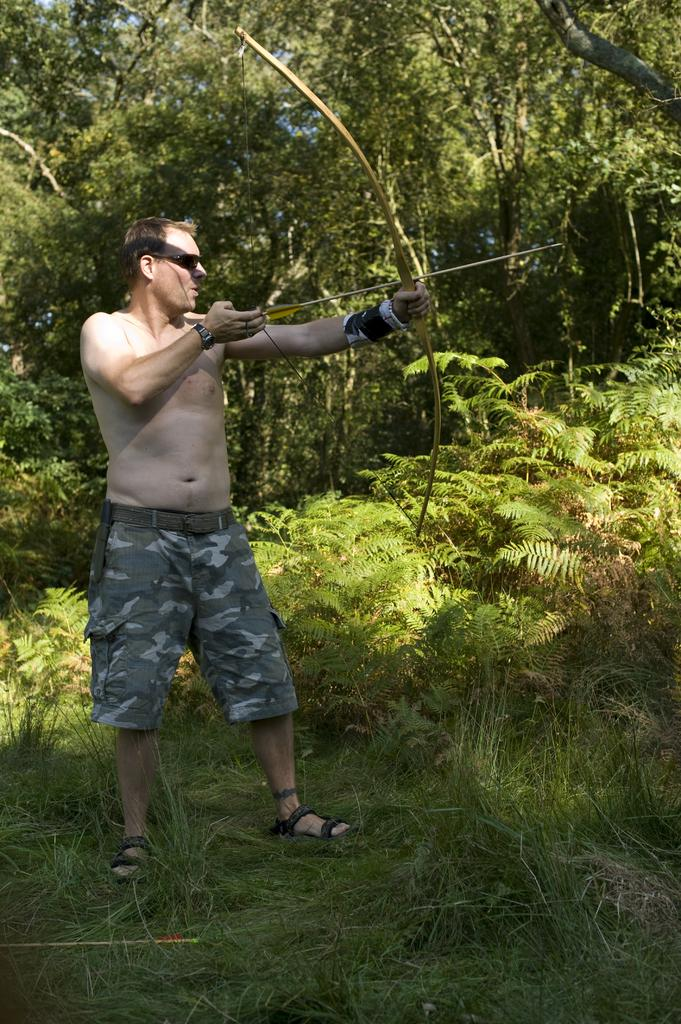What is the main subject of the image? There is a man in the image. What is the man doing in the image? The man is standing on the ground and holding a bow and an arrow in his hands. What is the ground covered with in the image? There is grass on the ground. What can be seen in the background of the image? There are trees and plants in the background of the image. What type of thread is the man using to tie the animals together in the image? There are no animals or thread present in the image; it only features a man holding a bow and an arrow. 